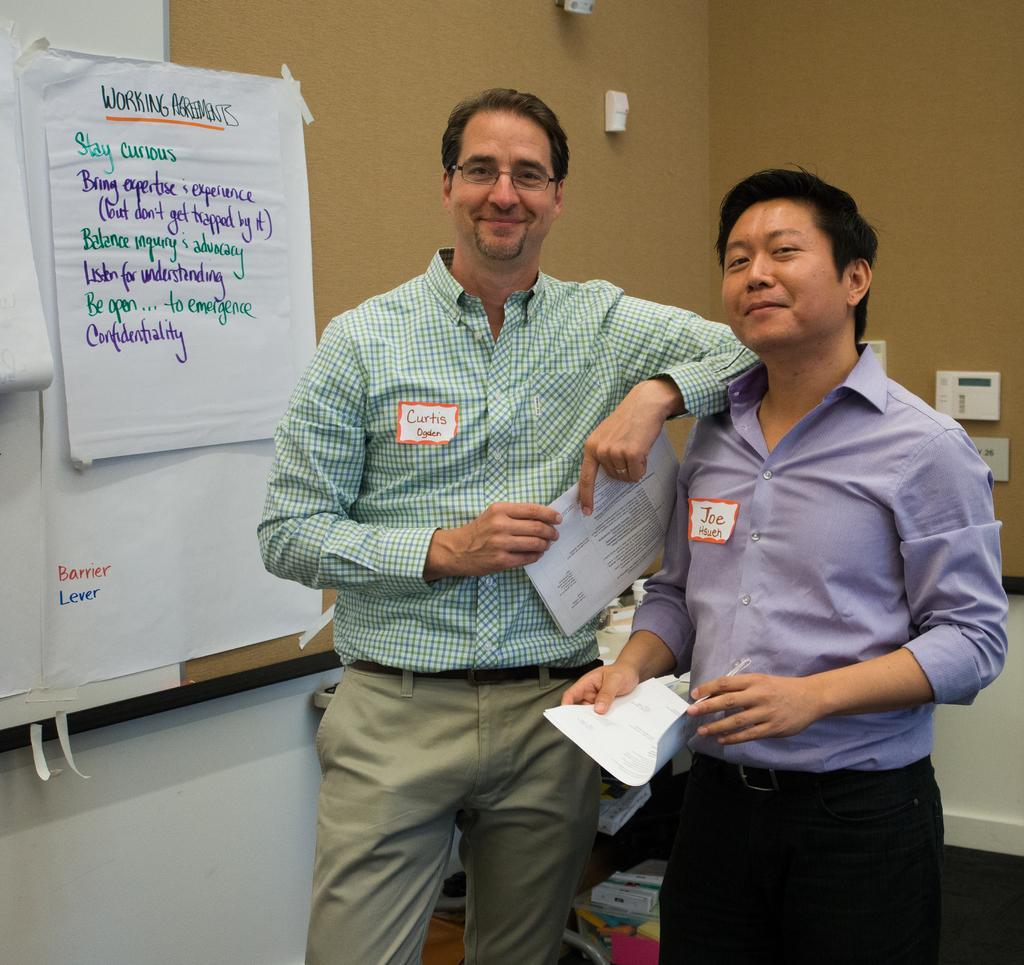Can you describe this image briefly? In this image I can see two people standing and holding papers. Back I can see few papers attached to the board. I can see few objects at back. 